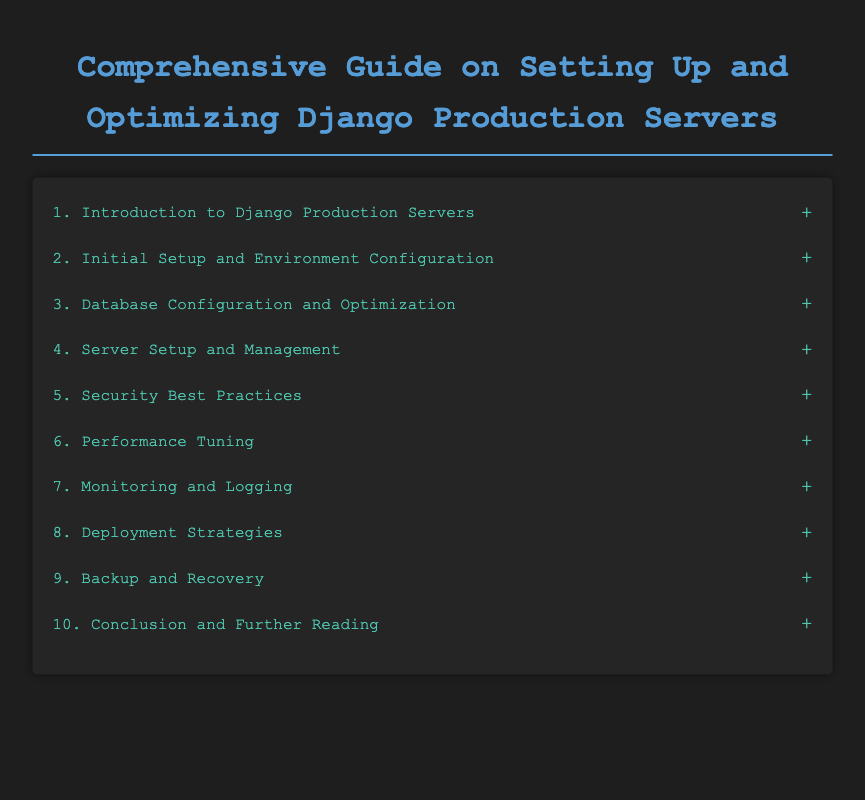What is the first chapter about? The first chapter is titled "Introduction to Django Production Servers" which indicates it covers topics related to Django's production environment.
Answer: Introduction to Django Production Servers How many sections are there under chapter three? Chapter three, titled "Database Configuration and Optimization," has three sections listed beneath it.
Answer: 3 What is one recommended database in chapter three? In chapter three, one of the suggested databases is PostgreSQL, as noted in the section discussing database options.
Answer: PostgreSQL What chapter discusses security best practices? Chapter five focuses on security measures and practices to optimize Django servers.
Answer: Security Best Practices Which tool does chapter seven suggest for error tracking? In chapter seven, Sentry is mentioned as a tool for monitoring errors within the Django application context.
Answer: Sentry What is the last section of the document? The last section is titled "Useful Tools and Resources," which indicates useful aids for Django developers.
Answer: Useful Tools and Resources How many chapters are present in the document? The document contains ten chapters covering various topics related to setting up and optimizing Django production servers.
Answer: 10 What type of configuration is discussed in section four-two? Section four-two covers reverse proxy configuration, which is crucial for server management and communication.
Answer: Reverse Proxy Configuration What is the focus of chapter eight? Chapter eight addresses deployment strategies to optimize and streamline application deployment processes.
Answer: Deployment Strategies 